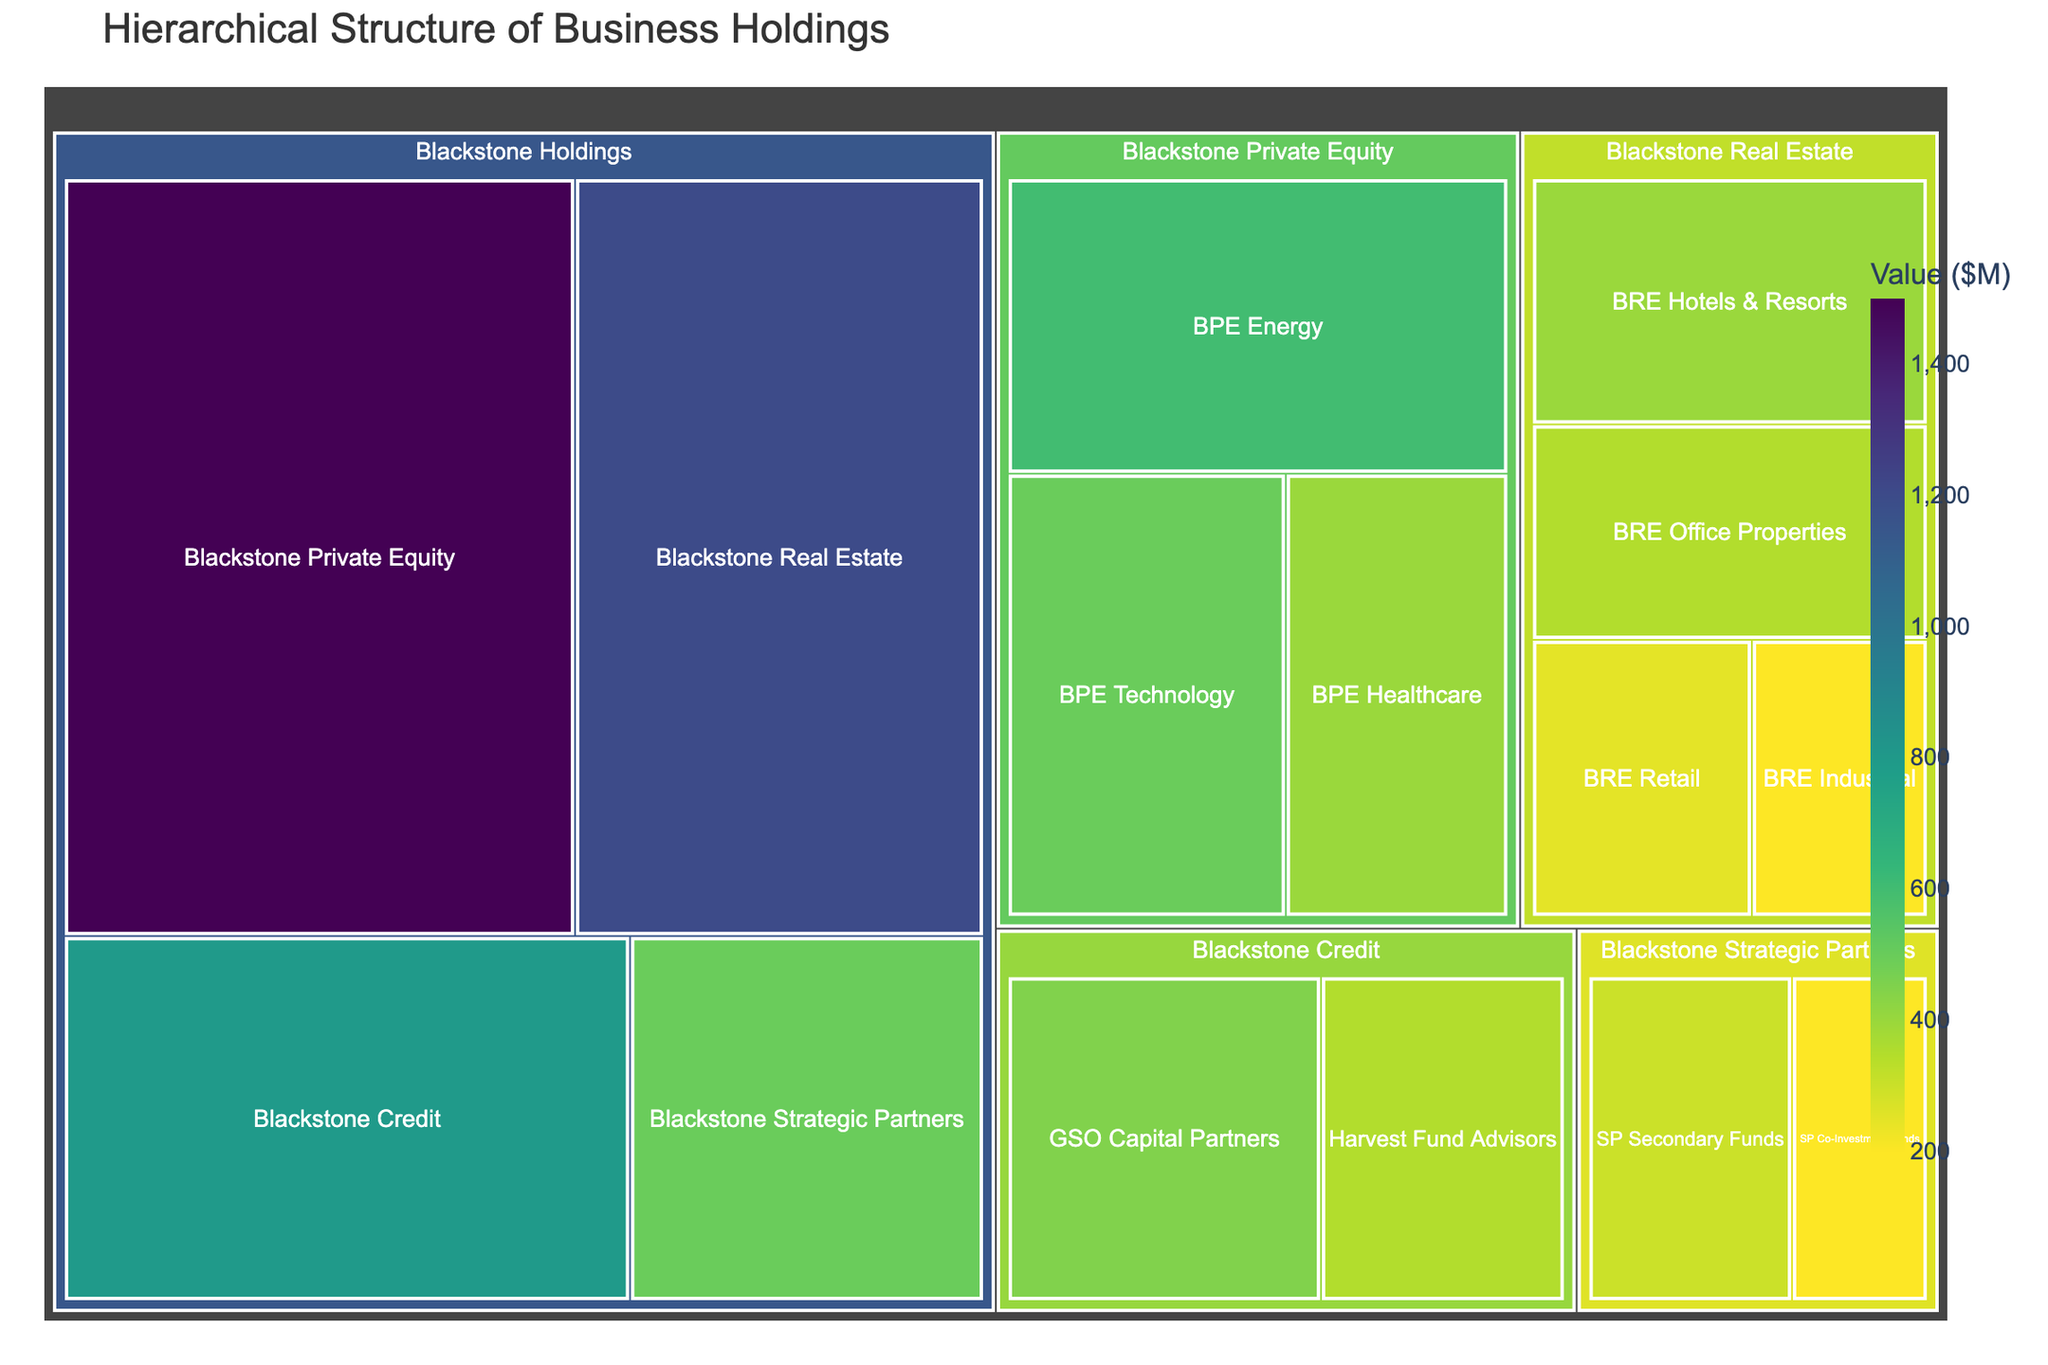Which business holding has the highest value? By looking at the top level of the treemap, we can quickly see which parent rectangle is the largest.
Answer: Blackstone Private Equity What is the total value of Blackstone Real Estate's subsidiaries? Sum the values of the children under Blackstone Real Estate: 400 + 350 + 250 + 200. This gives 1200.
Answer: 1200 Which has a higher value, GSO Capital Partners or Harvest Fund Advisors? By comparing the sizes or the values directly given for both: GSO Capital Partners has a value of 450, and Harvest Fund Advisors has a value of 350.
Answer: GSO Capital Partners What is the value difference between Blackstone Private Equity and Blackstone Credit? Subtract the value of Blackstone Credit (800) from Blackstone Private Equity (1500): 1500 - 800
Answer: 700 Which Blackstone Real Estate subsidiary has the smallest value? Among BRE Hotels & Resorts (400), BRE Office Properties (350), BRE Retail (250), and BRE Industrial (200), the smallest is BRE Industrial with 200.
Answer: BRE Industrial How many primary business holdings are there under Blackstone Holdings? At the top level, count the distinct parent categories within Blackstone Holdings: Blackstone Real Estate, Blackstone Private Equity, Blackstone Credit, and Blackstone Strategic Partners. This makes 4.
Answer: 4 If we sum the value of all subsidiaries under Blackstone Holdings, what total do we get? Add the value of all children under Blackstone Holdings: 1200 + 1500 + 800 + 500 = 4000. Then add the sum of their respective subsidiaries: 400 + 350 + 250 + 200 + 600 + 500 + 400 + 450 + 350 + 300 + 200 (this sums up to 4000). Therefore, the total is 4000 + 4000 = 8000.
Answer: 8000 